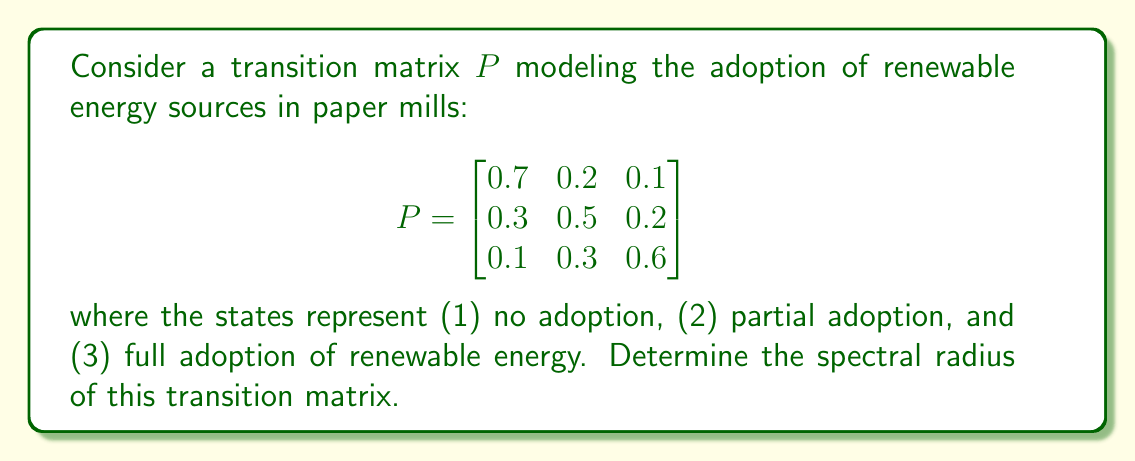Solve this math problem. To find the spectral radius of the transition matrix $P$, we need to follow these steps:

1) First, recall that the spectral radius $\rho(P)$ is the largest absolute value of the eigenvalues of $P$.

2) To find the eigenvalues, we need to solve the characteristic equation:

   $\det(P - \lambda I) = 0$

3) Expanding this determinant:

   $$\begin{vmatrix}
   0.7-\lambda & 0.2 & 0.1 \\
   0.3 & 0.5-\lambda & 0.2 \\
   0.1 & 0.3 & 0.6-\lambda
   \end{vmatrix} = 0$$

4) This gives us the characteristic polynomial:

   $-\lambda^3 + 1.8\lambda^2 - 0.97\lambda + 0.16 = 0$

5) Solving this cubic equation (using a computer algebra system or numerical methods), we get the eigenvalues:

   $\lambda_1 \approx 1$
   $\lambda_2 \approx 0.4472$
   $\lambda_3 \approx 0.3528$

6) The spectral radius is the largest absolute value among these eigenvalues:

   $\rho(P) = \max(|\lambda_1|, |\lambda_2|, |\lambda_3|) = |\lambda_1| \approx 1$

7) Note that for a stochastic matrix like this transition matrix, the spectral radius is always 1, which serves as a good check for our calculation.
Answer: $\rho(P) = 1$ 